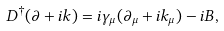<formula> <loc_0><loc_0><loc_500><loc_500>D ^ { \dagger } ( \partial + i k ) = i \gamma _ { \mu } ( \partial _ { \mu } + i k _ { \mu } ) - i B ,</formula> 